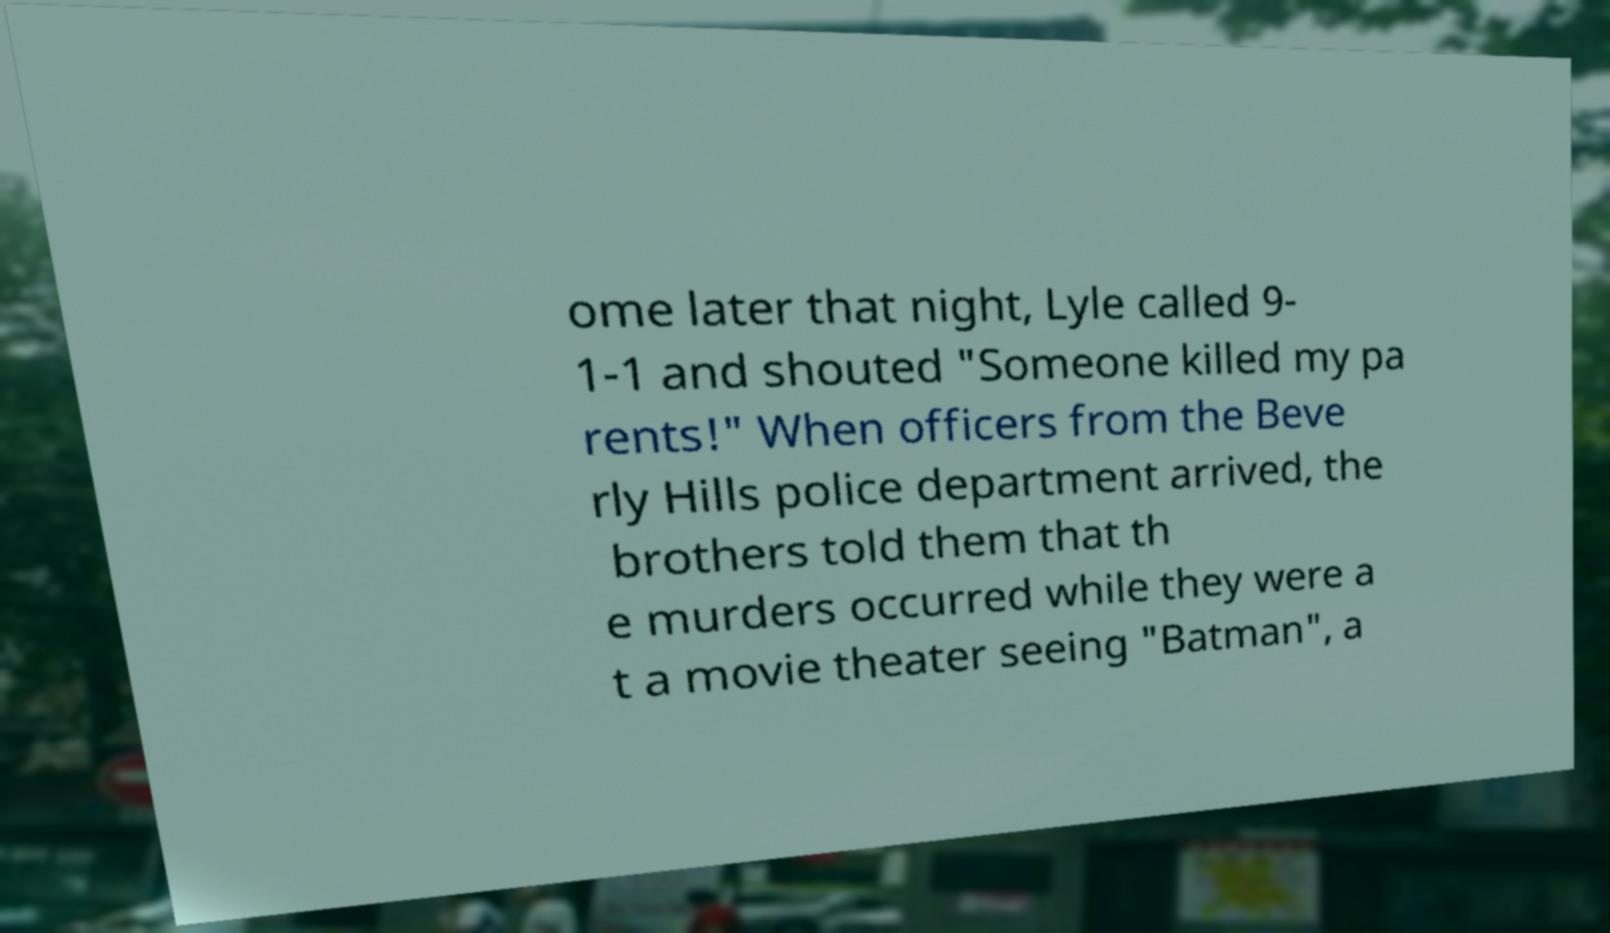Please identify and transcribe the text found in this image. ome later that night, Lyle called 9- 1-1 and shouted "Someone killed my pa rents!" When officers from the Beve rly Hills police department arrived, the brothers told them that th e murders occurred while they were a t a movie theater seeing "Batman", a 